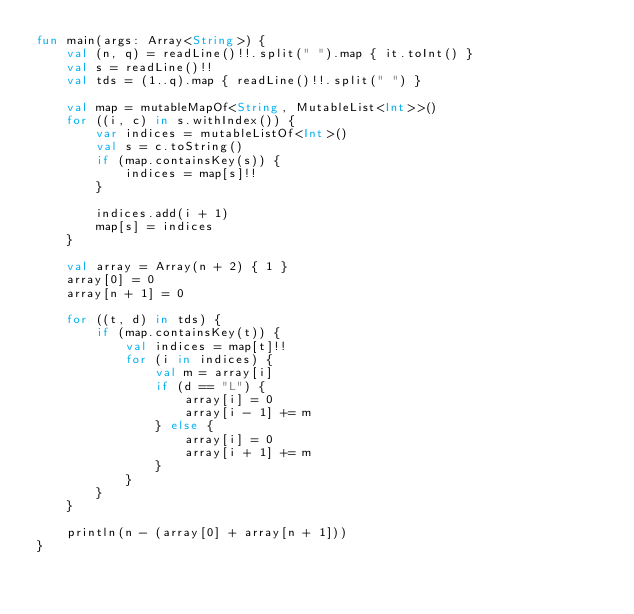Convert code to text. <code><loc_0><loc_0><loc_500><loc_500><_Kotlin_>fun main(args: Array<String>) {
    val (n, q) = readLine()!!.split(" ").map { it.toInt() }
    val s = readLine()!!
    val tds = (1..q).map { readLine()!!.split(" ") }

    val map = mutableMapOf<String, MutableList<Int>>()
    for ((i, c) in s.withIndex()) {
        var indices = mutableListOf<Int>()
        val s = c.toString()
        if (map.containsKey(s)) {
            indices = map[s]!!
        }

        indices.add(i + 1)
        map[s] = indices
    }

    val array = Array(n + 2) { 1 }
    array[0] = 0
    array[n + 1] = 0

    for ((t, d) in tds) {
        if (map.containsKey(t)) {
            val indices = map[t]!!
            for (i in indices) {
                val m = array[i]
                if (d == "L") {
                    array[i] = 0
                    array[i - 1] += m
                } else {
                    array[i] = 0
                    array[i + 1] += m
                }
            }
        }
    }

    println(n - (array[0] + array[n + 1]))
}</code> 